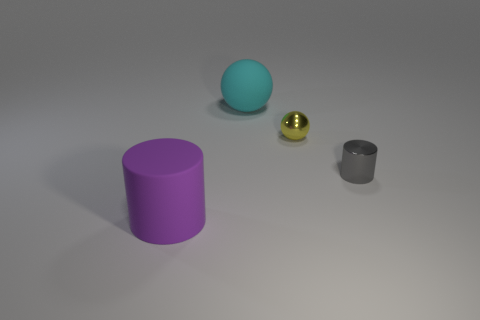Add 2 gray metallic objects. How many objects exist? 6 Add 3 big cyan balls. How many big cyan balls exist? 4 Subtract 0 purple cubes. How many objects are left? 4 Subtract all gray metal things. Subtract all big purple matte things. How many objects are left? 2 Add 4 cyan objects. How many cyan objects are left? 5 